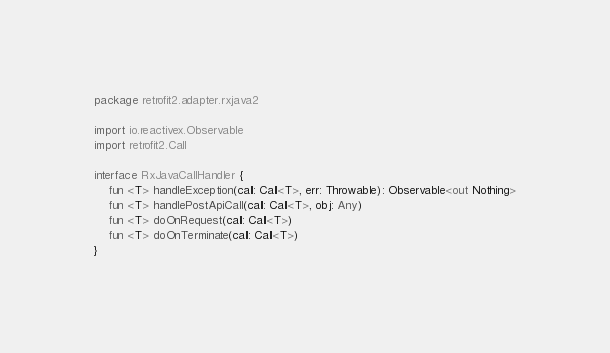<code> <loc_0><loc_0><loc_500><loc_500><_Kotlin_>package retrofit2.adapter.rxjava2

import io.reactivex.Observable
import retrofit2.Call

interface RxJavaCallHandler {
    fun <T> handleException(call: Call<T>, err: Throwable): Observable<out Nothing>
    fun <T> handlePostApiCall(call: Call<T>, obj: Any)
    fun <T> doOnRequest(call: Call<T>)
    fun <T> doOnTerminate(call: Call<T>)
}</code> 